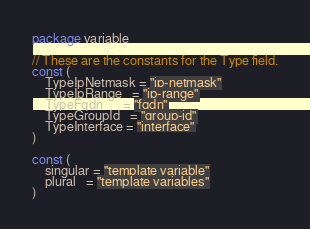Convert code to text. <code><loc_0><loc_0><loc_500><loc_500><_Go_>package variable

// These are the constants for the Type field.
const (
	TypeIpNetmask = "ip-netmask"
	TypeIpRange   = "ip-range"
	TypeFqdn      = "fqdn"
	TypeGroupId   = "group-id"
	TypeInterface = "interface"
)

const (
	singular = "template variable"
	plural   = "template variables"
)
</code> 